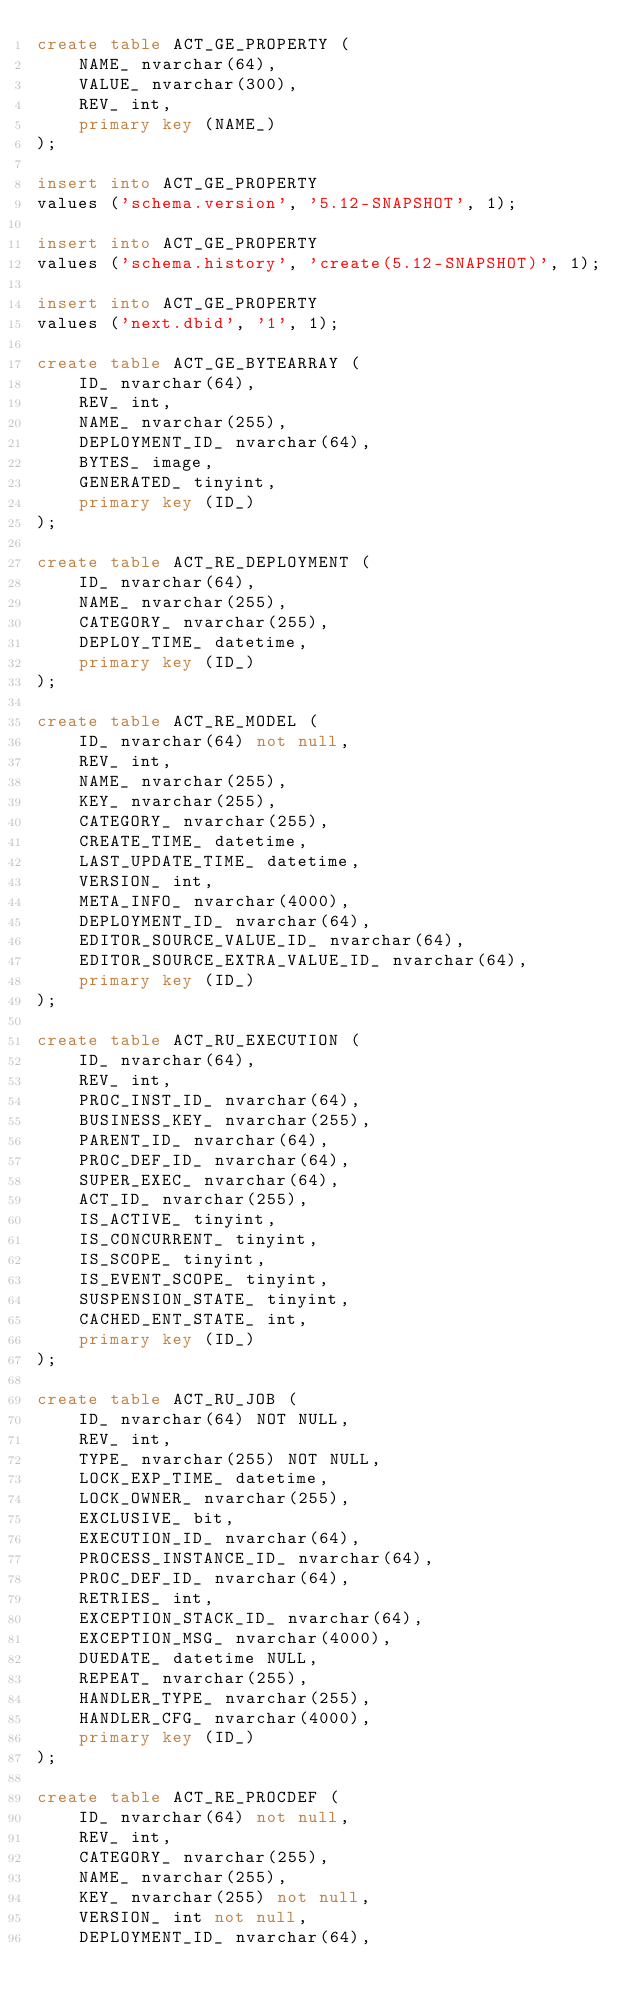<code> <loc_0><loc_0><loc_500><loc_500><_SQL_>create table ACT_GE_PROPERTY (
    NAME_ nvarchar(64),
    VALUE_ nvarchar(300),
    REV_ int,
    primary key (NAME_)
);

insert into ACT_GE_PROPERTY
values ('schema.version', '5.12-SNAPSHOT', 1);

insert into ACT_GE_PROPERTY
values ('schema.history', 'create(5.12-SNAPSHOT)', 1);

insert into ACT_GE_PROPERTY
values ('next.dbid', '1', 1);

create table ACT_GE_BYTEARRAY (
    ID_ nvarchar(64),
    REV_ int,
    NAME_ nvarchar(255),
    DEPLOYMENT_ID_ nvarchar(64),
    BYTES_ image,
    GENERATED_ tinyint,
    primary key (ID_)
);

create table ACT_RE_DEPLOYMENT (
    ID_ nvarchar(64),
    NAME_ nvarchar(255),
    CATEGORY_ nvarchar(255),
    DEPLOY_TIME_ datetime,
    primary key (ID_)
);

create table ACT_RE_MODEL (
    ID_ nvarchar(64) not null,
    REV_ int,
    NAME_ nvarchar(255),
    KEY_ nvarchar(255),
    CATEGORY_ nvarchar(255),
    CREATE_TIME_ datetime,
    LAST_UPDATE_TIME_ datetime,
    VERSION_ int,
    META_INFO_ nvarchar(4000),
    DEPLOYMENT_ID_ nvarchar(64),
    EDITOR_SOURCE_VALUE_ID_ nvarchar(64),
    EDITOR_SOURCE_EXTRA_VALUE_ID_ nvarchar(64),
    primary key (ID_)
);

create table ACT_RU_EXECUTION (
    ID_ nvarchar(64),
    REV_ int,
    PROC_INST_ID_ nvarchar(64),
    BUSINESS_KEY_ nvarchar(255),
    PARENT_ID_ nvarchar(64),
    PROC_DEF_ID_ nvarchar(64),
    SUPER_EXEC_ nvarchar(64),
    ACT_ID_ nvarchar(255),
    IS_ACTIVE_ tinyint,
    IS_CONCURRENT_ tinyint,
    IS_SCOPE_ tinyint,
    IS_EVENT_SCOPE_ tinyint,
    SUSPENSION_STATE_ tinyint,
    CACHED_ENT_STATE_ int,
    primary key (ID_)
);

create table ACT_RU_JOB (
    ID_ nvarchar(64) NOT NULL,
	REV_ int,
    TYPE_ nvarchar(255) NOT NULL,
    LOCK_EXP_TIME_ datetime,
    LOCK_OWNER_ nvarchar(255),
    EXCLUSIVE_ bit,
    EXECUTION_ID_ nvarchar(64),
    PROCESS_INSTANCE_ID_ nvarchar(64),
    PROC_DEF_ID_ nvarchar(64),
    RETRIES_ int,
    EXCEPTION_STACK_ID_ nvarchar(64),
    EXCEPTION_MSG_ nvarchar(4000),
    DUEDATE_ datetime NULL,
    REPEAT_ nvarchar(255),
    HANDLER_TYPE_ nvarchar(255),
    HANDLER_CFG_ nvarchar(4000),
    primary key (ID_)
);

create table ACT_RE_PROCDEF (
    ID_ nvarchar(64) not null,
    REV_ int,
    CATEGORY_ nvarchar(255),
    NAME_ nvarchar(255),
    KEY_ nvarchar(255) not null,
    VERSION_ int not null,
    DEPLOYMENT_ID_ nvarchar(64),</code> 